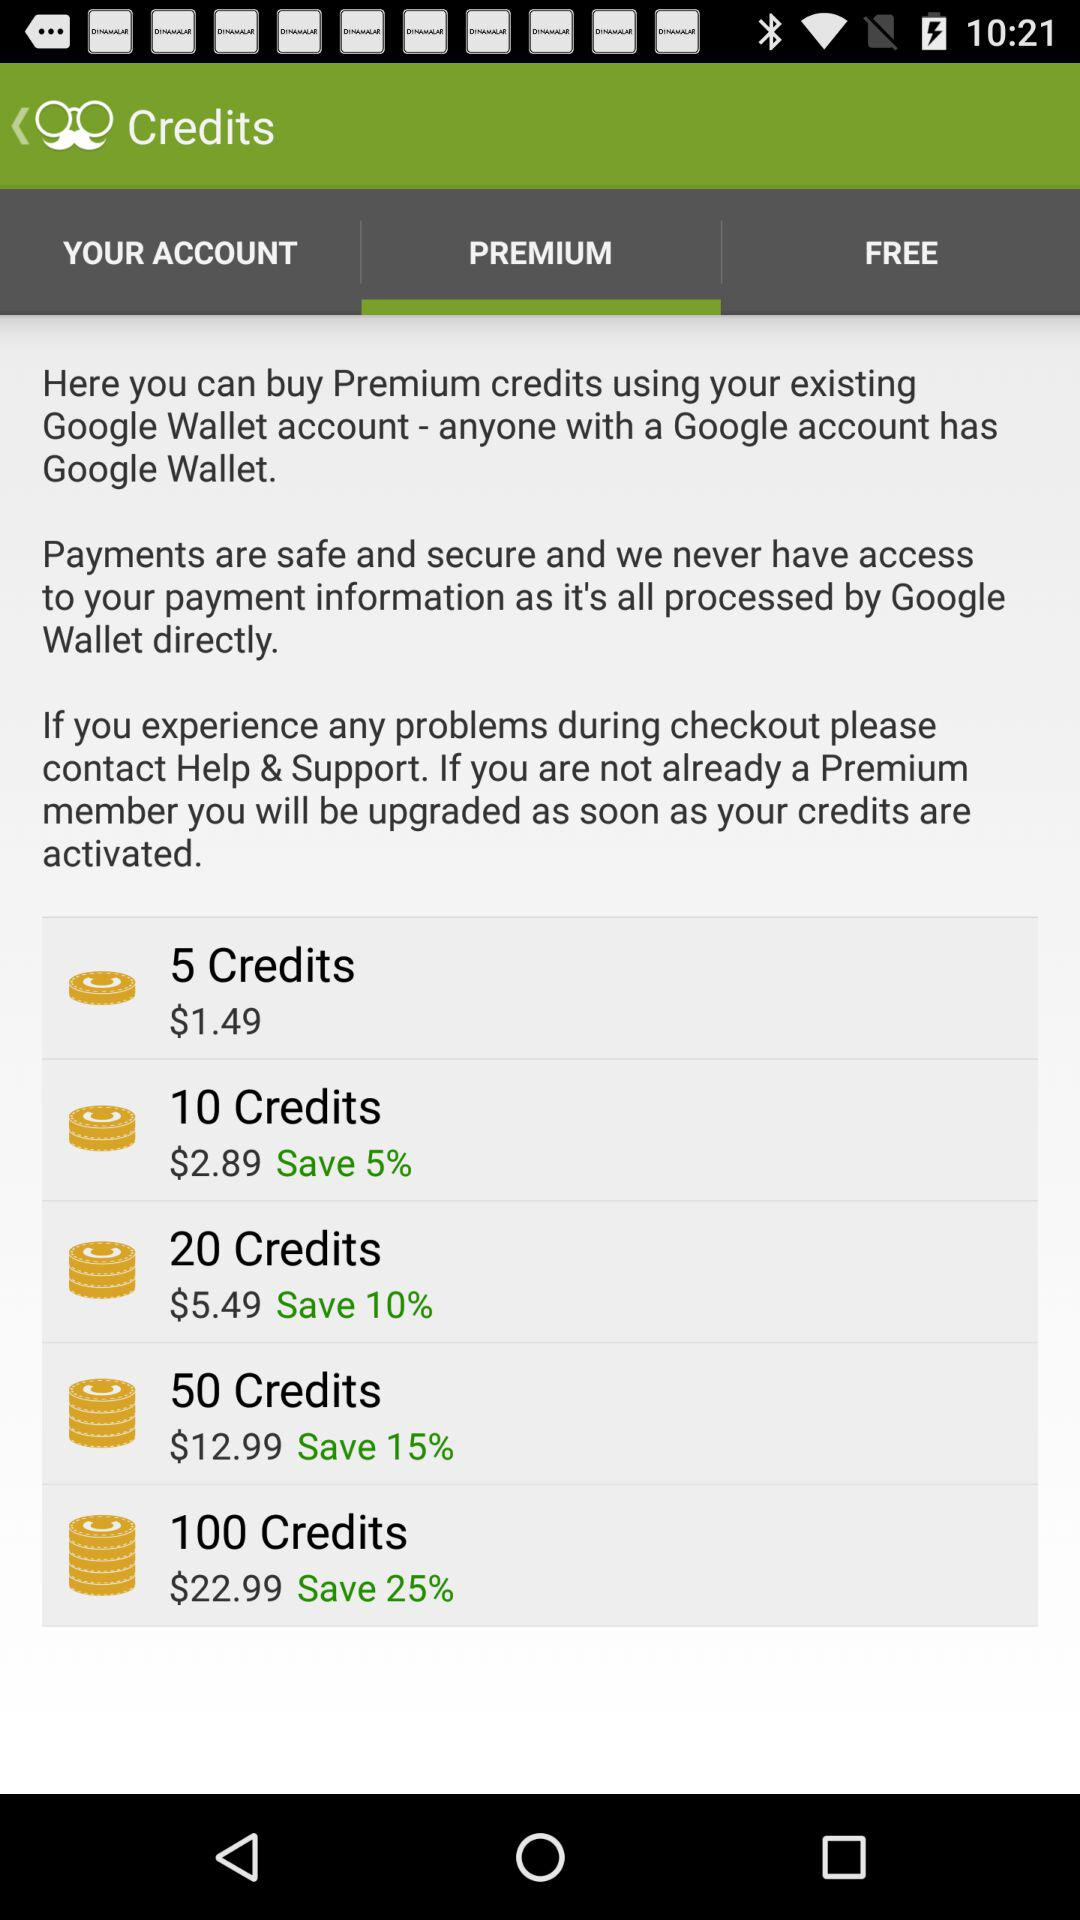How much more does the 100 credit package cost than the 50 credit package?
Answer the question using a single word or phrase. $10.00 